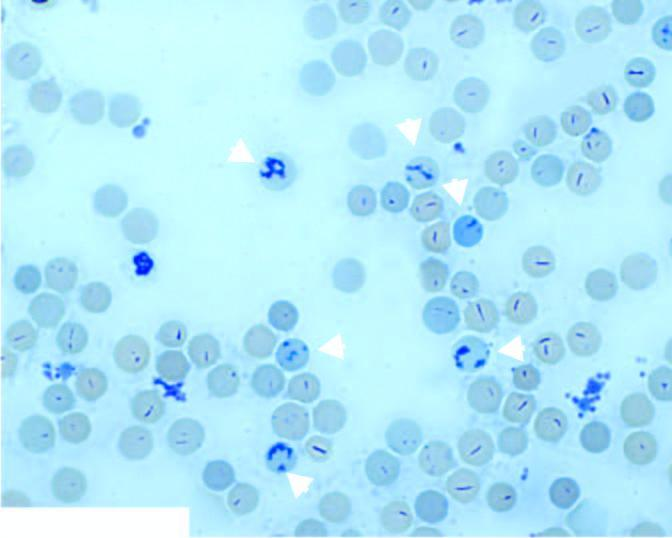what in blood is seen in blood stained by supravital dye, new methylene blue?
Answer the question using a single word or phrase. Reticulocytes in blood 